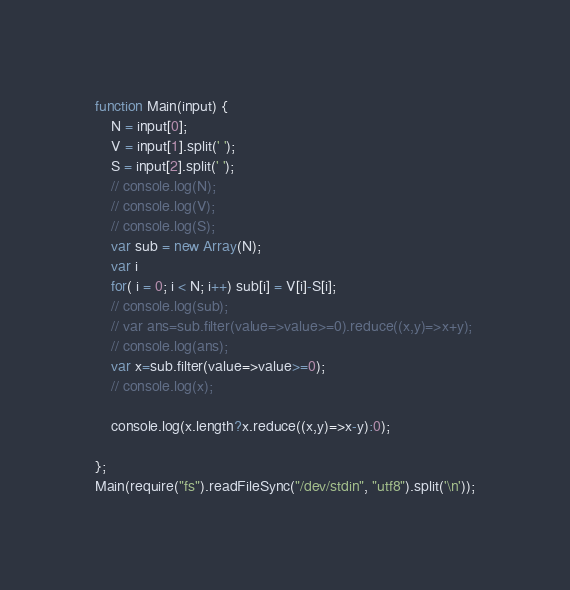<code> <loc_0><loc_0><loc_500><loc_500><_JavaScript_>function Main(input) {
    N = input[0];
    V = input[1].split(' ');
    S = input[2].split(' ');
    // console.log(N);
    // console.log(V);
    // console.log(S);
    var sub = new Array(N);
    var i
    for( i = 0; i < N; i++) sub[i] = V[i]-S[i];
    // console.log(sub);
    // var ans=sub.filter(value=>value>=0).reduce((x,y)=>x+y);
    // console.log(ans);
    var x=sub.filter(value=>value>=0);
    // console.log(x);
    
    console.log(x.length?x.reduce((x,y)=>x-y):0);
    
};
Main(require("fs").readFileSync("/dev/stdin", "utf8").split('\n'));
</code> 